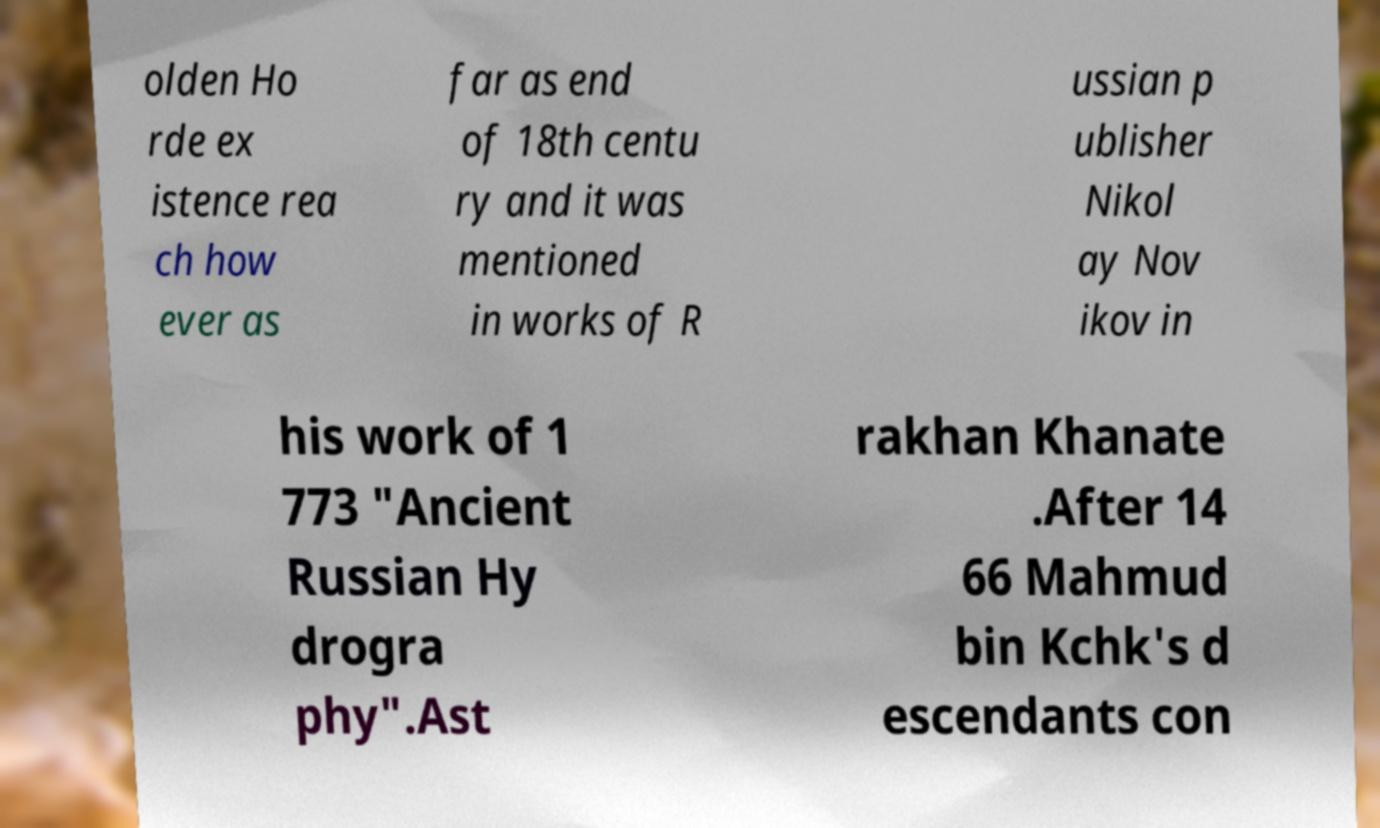Could you extract and type out the text from this image? olden Ho rde ex istence rea ch how ever as far as end of 18th centu ry and it was mentioned in works of R ussian p ublisher Nikol ay Nov ikov in his work of 1 773 "Ancient Russian Hy drogra phy".Ast rakhan Khanate .After 14 66 Mahmud bin Kchk's d escendants con 